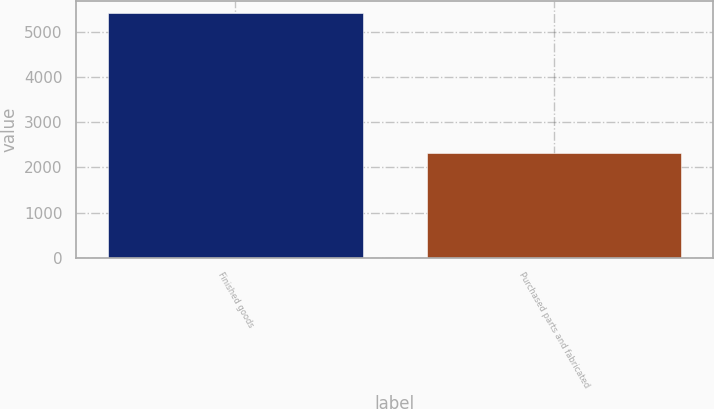Convert chart to OTSL. <chart><loc_0><loc_0><loc_500><loc_500><bar_chart><fcel>Finished goods<fcel>Purchased parts and fabricated<nl><fcel>5424<fcel>2326<nl></chart> 